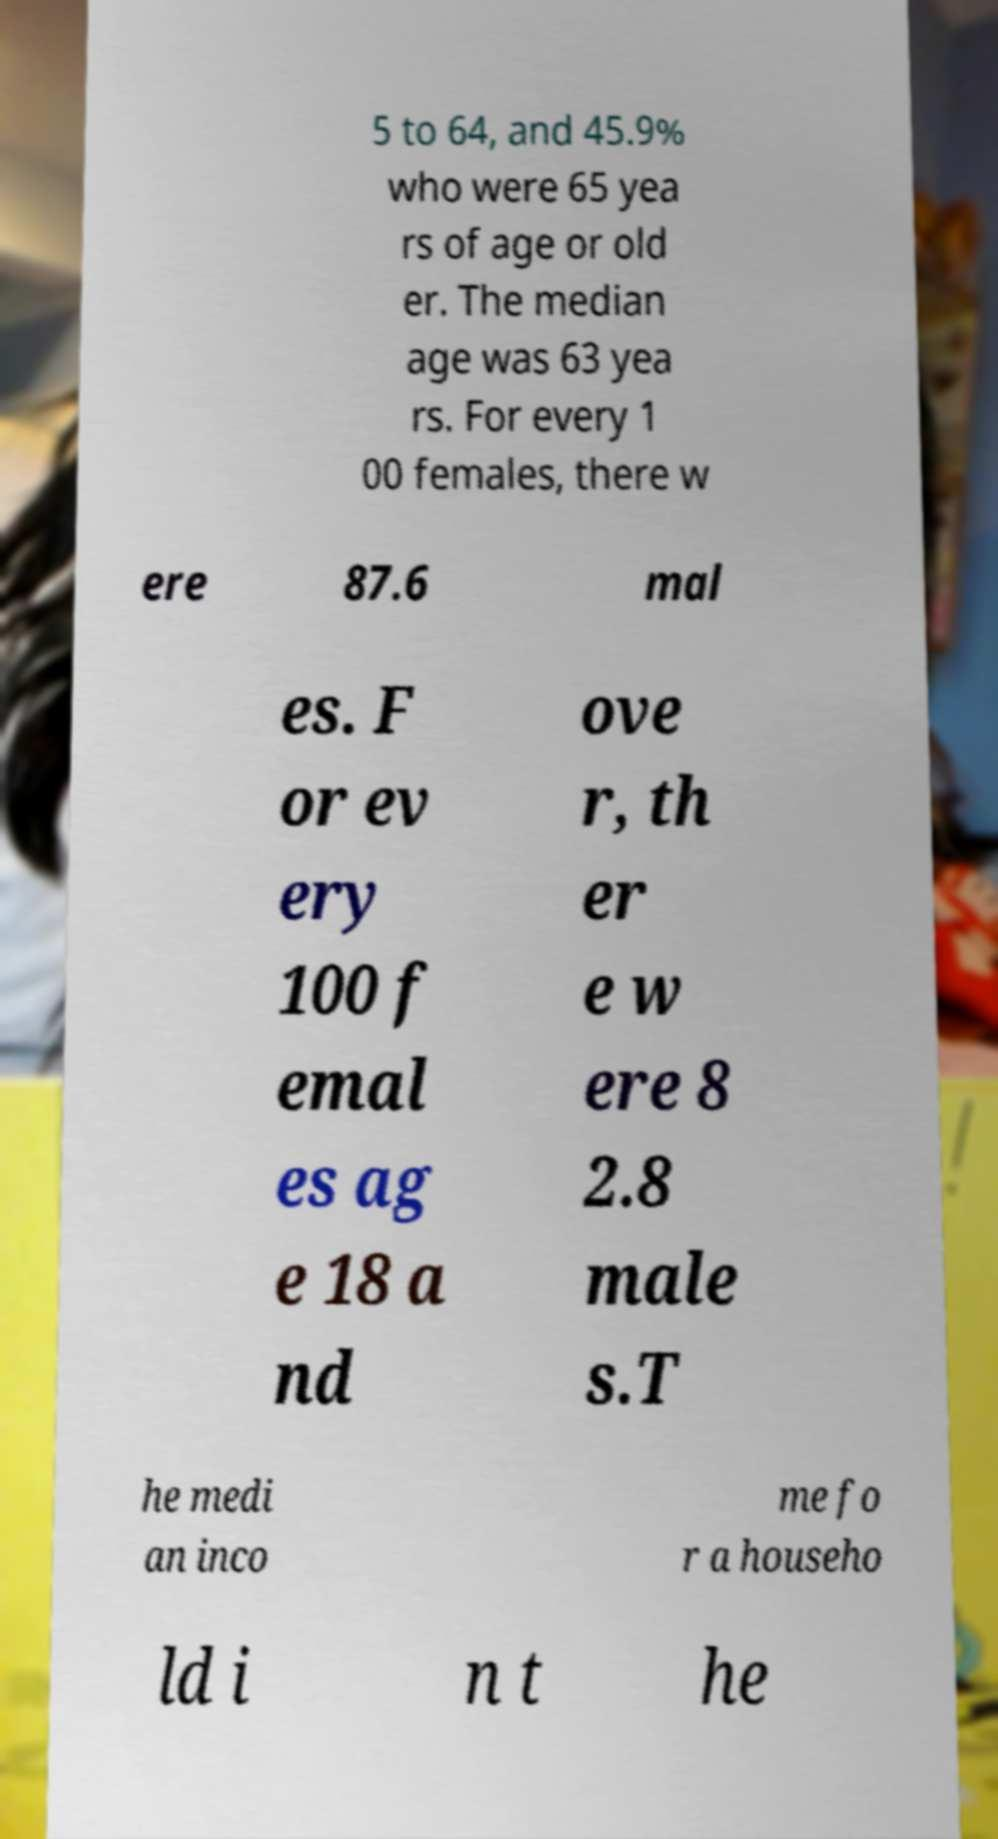Can you read and provide the text displayed in the image?This photo seems to have some interesting text. Can you extract and type it out for me? 5 to 64, and 45.9% who were 65 yea rs of age or old er. The median age was 63 yea rs. For every 1 00 females, there w ere 87.6 mal es. F or ev ery 100 f emal es ag e 18 a nd ove r, th er e w ere 8 2.8 male s.T he medi an inco me fo r a househo ld i n t he 